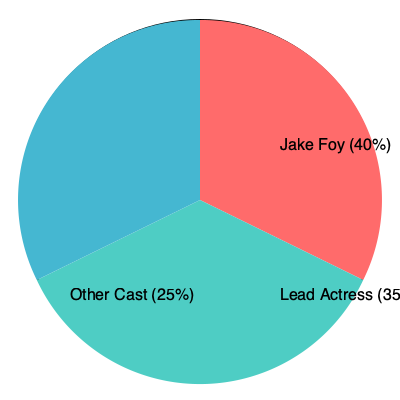In the pie chart representing screen time distribution for a Canadian TV show, Jake Foy's portion is 40%. If the entire show has a runtime of 600 minutes, how many minutes of screen time does Jake Foy have? To solve this problem, we'll follow these steps:

1. Understand the given information:
   - Jake Foy's portion of screen time is 40% of the total.
   - The total runtime of the show is 600 minutes.

2. Calculate Jake Foy's screen time:
   - We need to find 40% of 600 minutes.
   - This can be expressed as: $40\% \times 600$ minutes
   - To calculate a percentage, we divide by 100: $(40 \div 100) \times 600$ minutes
   - Simplify: $0.4 \times 600$ minutes

3. Perform the multiplication:
   $0.4 \times 600 = 240$ minutes

Therefore, Jake Foy has 240 minutes of screen time in the show.
Answer: 240 minutes 